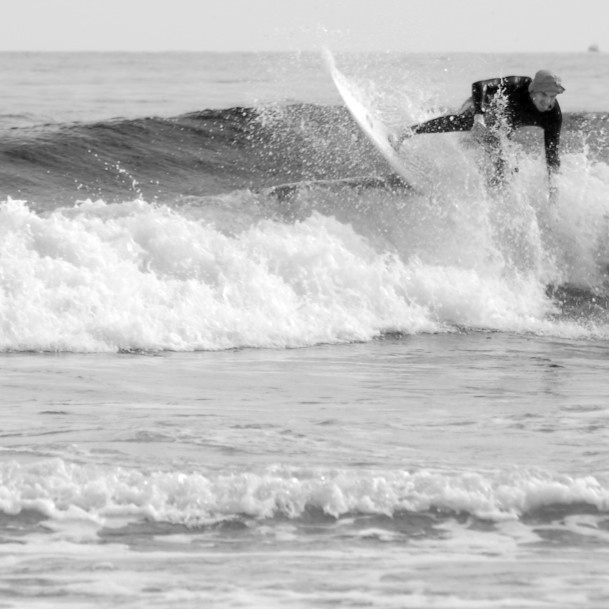Describe the objects in this image and their specific colors. I can see people in gainsboro, black, gray, darkgray, and lightgray tones and surfboard in lightgray, darkgray, and gray tones in this image. 